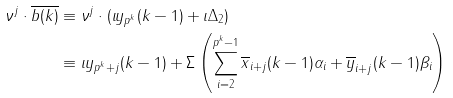Convert formula to latex. <formula><loc_0><loc_0><loc_500><loc_500>\nu ^ { j } \cdot \overline { b ( k ) } & \equiv \nu ^ { j } \cdot ( \iota y _ { p ^ { k } } ( k - 1 ) + \iota \Delta _ { 2 } ) \\ & \equiv \iota y _ { p ^ { k } + j } ( k - 1 ) + \Sigma \left ( \sum ^ { p ^ { k } - 1 } _ { i = 2 } \overline { x } _ { i + j } ( k - 1 ) \alpha _ { i } + \overline { y } _ { i + j } ( k - 1 ) \beta _ { i } \right )</formula> 